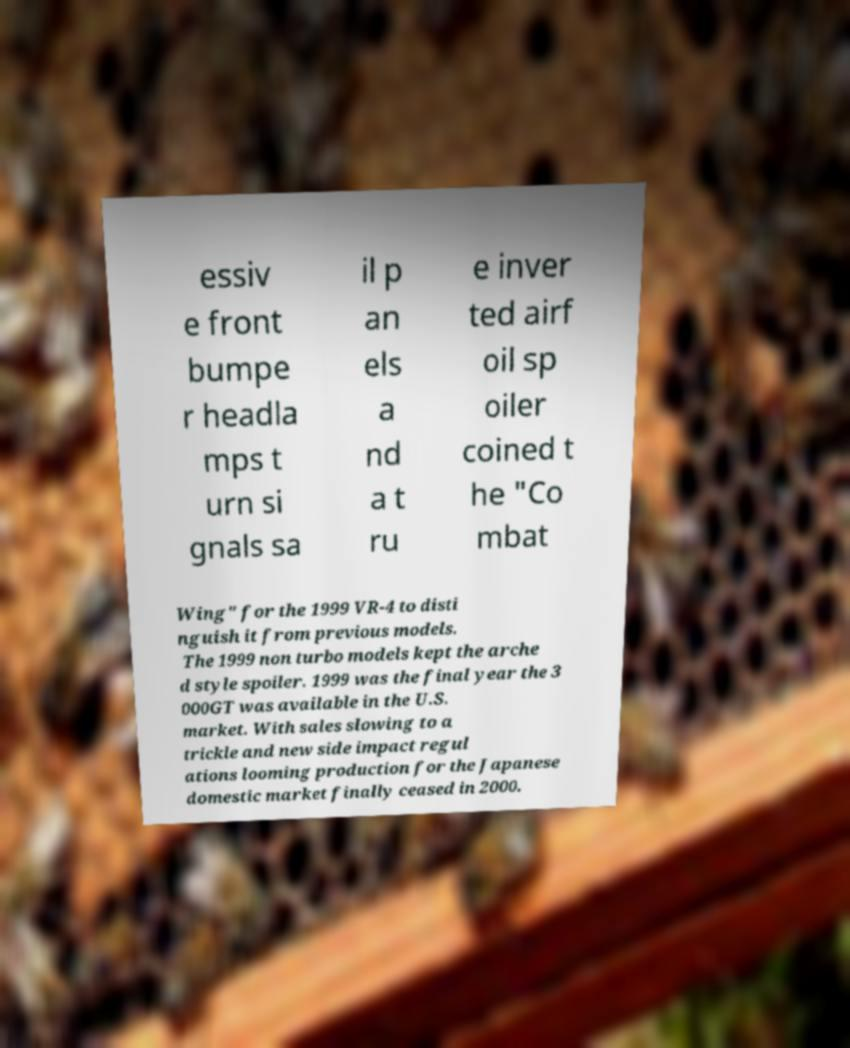For documentation purposes, I need the text within this image transcribed. Could you provide that? essiv e front bumpe r headla mps t urn si gnals sa il p an els a nd a t ru e inver ted airf oil sp oiler coined t he "Co mbat Wing" for the 1999 VR-4 to disti nguish it from previous models. The 1999 non turbo models kept the arche d style spoiler. 1999 was the final year the 3 000GT was available in the U.S. market. With sales slowing to a trickle and new side impact regul ations looming production for the Japanese domestic market finally ceased in 2000. 